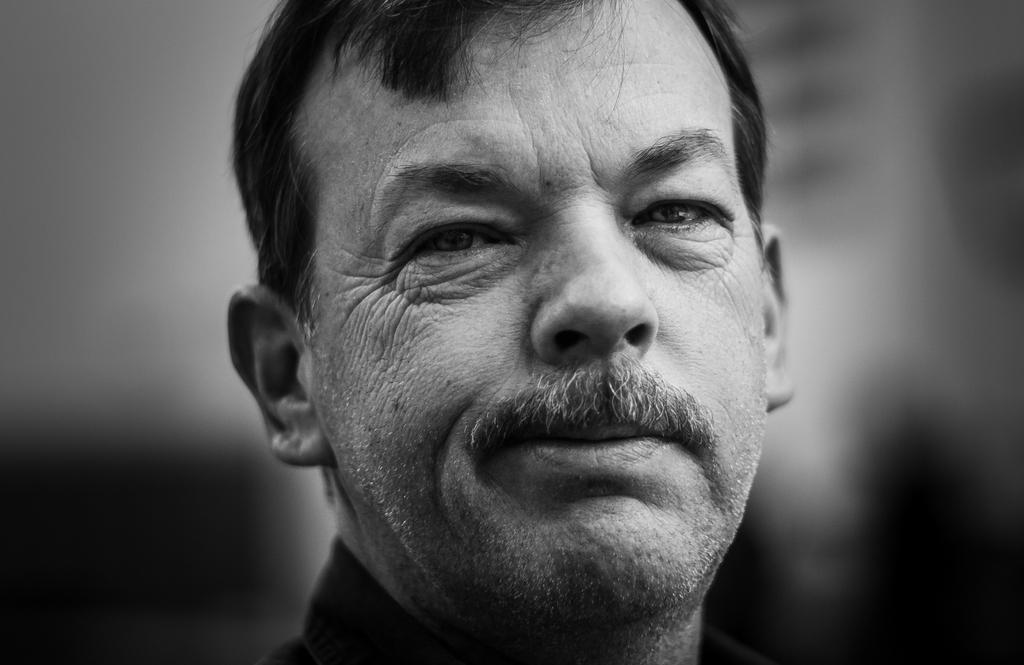Could you give a brief overview of what you see in this image? In the image we can see there is a face of a man and the image is in black and white colour. 